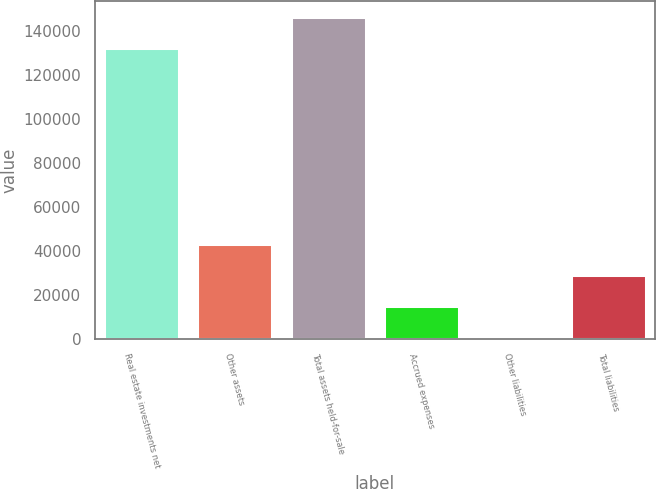Convert chart to OTSL. <chart><loc_0><loc_0><loc_500><loc_500><bar_chart><fcel>Real estate investments net<fcel>Other assets<fcel>Total assets held-for-sale<fcel>Accrued expenses<fcel>Other liabilities<fcel>Total liabilities<nl><fcel>132194<fcel>43411.5<fcel>146328<fcel>15144.5<fcel>1011<fcel>29278<nl></chart> 